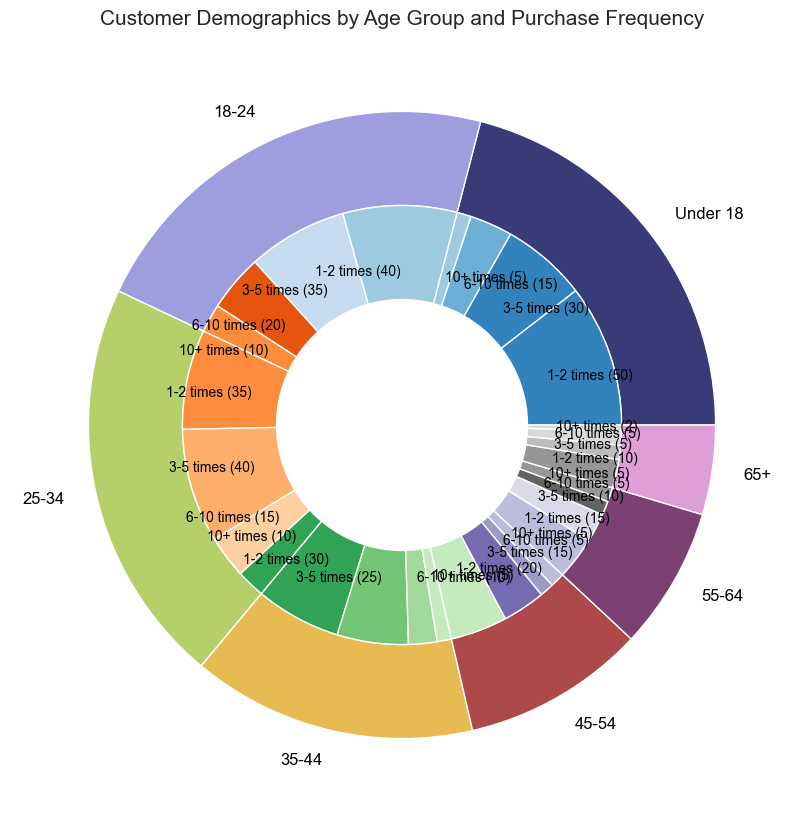Which age group has the highest total purchase count? From the outer pie chart representing age groups, identify the segment with the largest size. This indicates the age group with the highest total purchase count. The "Under 18" segment looks largest.
Answer: Under 18 Which purchase frequency within the "18-24" age group has the highest count? From the inner pie segments corresponding to the "18-24" outer segment, identify the segment with the largest size. The "3-5 times" segment looks largest within the "18-24" group.
Answer: 3-5 times What is the total count for the "45-54" age group? From the outer pie chart, identify the segment corresponding to "45-54". The total count can be verified by summing the inner segments within the "45-54" outer segment. The counts are 20 + 15 + 5 + 5 = 45.
Answer: 45 Which age group has the least frequent buyers (1-2 times purchases) totaling to the smallest count? From the inner pie chart, compare the sizes of the "1-2 times" segments across all age groups. The smallest "1-2 times" segment appears to be in the "65+" age group.
Answer: 65+ Which purchase frequency has the smallest count across all age groups? Identify the smallest inner pie segment regardless of the outer pie segment (age group it is within). The "10+ times" segment in the "65+" group appears smallest.
Answer: 10+ times Compare the total counts for "Under 18" and "25-34" age groups. Which one is higher and by how much? From the outer pie chart look at the "Under 18" and "25-34" segments. "Under 18" total count is 100, and "25-34" total count is also 100. So, they are equal.
Answer: They are equal in total count Which age group has the highest number of purchases in the "6-10 times" category? From the inner pie chart, identify the largest "6-10 times" segment, and check which age group it belongs to. The largest "6-10 times" segment appears to be within the "18-24" age group.
Answer: 18-24 Which age group and purchase frequency combination has a total count of 5? Scan through the inner pie chart labels indicating each purchase frequency. The "Under 18" and "10+ times" combination has a count of 5.
Answer: Under 18 and 10+ times What is the combined count of "10+ times" purchases for the "25-34" and "35-44" age groups? Identify the "10+ times" segments within the "25-34" and "35-44" age groups from the inner pie chart and sum their counts. The counts are 10 + 5 = 15.
Answer: 15 Which purchase frequency appears to be most common among the "55-64" age group? From the inner pie chart segments corresponding to the "55-64" outer segment, identify the largest inner segment. The "1-2 times" segment looks largest within the "55-64" group.
Answer: 1-2 times 